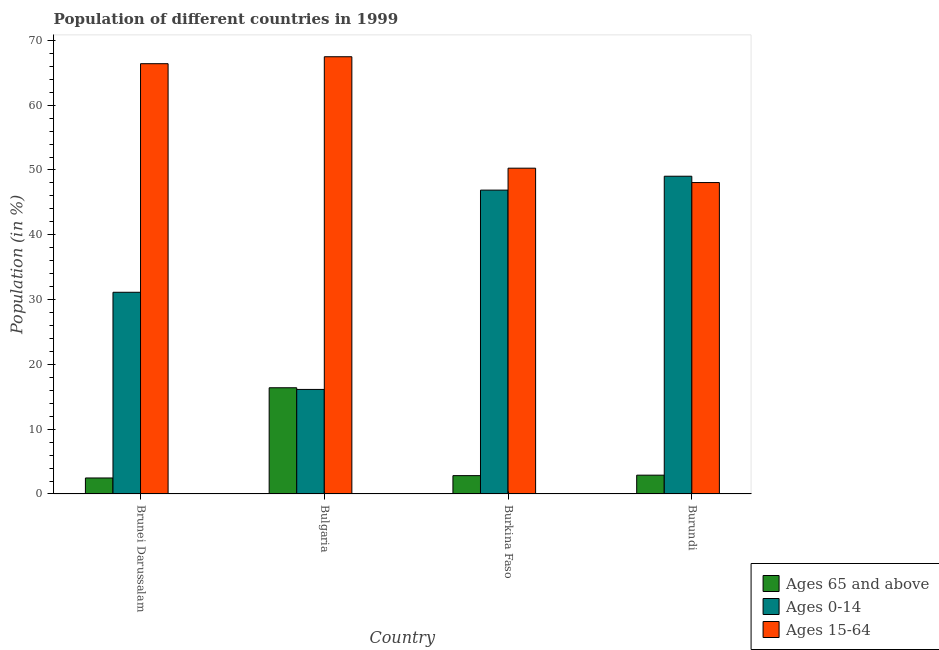How many different coloured bars are there?
Provide a succinct answer. 3. Are the number of bars per tick equal to the number of legend labels?
Your answer should be very brief. Yes. Are the number of bars on each tick of the X-axis equal?
Your response must be concise. Yes. How many bars are there on the 2nd tick from the right?
Give a very brief answer. 3. What is the label of the 1st group of bars from the left?
Your response must be concise. Brunei Darussalam. In how many cases, is the number of bars for a given country not equal to the number of legend labels?
Offer a terse response. 0. What is the percentage of population within the age-group 0-14 in Bulgaria?
Provide a succinct answer. 16.13. Across all countries, what is the maximum percentage of population within the age-group 15-64?
Provide a short and direct response. 67.48. Across all countries, what is the minimum percentage of population within the age-group 0-14?
Offer a very short reply. 16.13. In which country was the percentage of population within the age-group 0-14 maximum?
Make the answer very short. Burundi. In which country was the percentage of population within the age-group 0-14 minimum?
Provide a short and direct response. Bulgaria. What is the total percentage of population within the age-group of 65 and above in the graph?
Your response must be concise. 24.59. What is the difference between the percentage of population within the age-group of 65 and above in Burkina Faso and that in Burundi?
Offer a terse response. -0.07. What is the difference between the percentage of population within the age-group 0-14 in Brunei Darussalam and the percentage of population within the age-group 15-64 in Burundi?
Ensure brevity in your answer.  -16.93. What is the average percentage of population within the age-group 0-14 per country?
Give a very brief answer. 35.8. What is the difference between the percentage of population within the age-group 0-14 and percentage of population within the age-group of 65 and above in Brunei Darussalam?
Ensure brevity in your answer.  28.66. What is the ratio of the percentage of population within the age-group 15-64 in Brunei Darussalam to that in Burkina Faso?
Your answer should be compact. 1.32. Is the difference between the percentage of population within the age-group of 65 and above in Brunei Darussalam and Bulgaria greater than the difference between the percentage of population within the age-group 0-14 in Brunei Darussalam and Bulgaria?
Ensure brevity in your answer.  No. What is the difference between the highest and the second highest percentage of population within the age-group 0-14?
Offer a terse response. 2.14. What is the difference between the highest and the lowest percentage of population within the age-group 15-64?
Your response must be concise. 19.42. In how many countries, is the percentage of population within the age-group of 65 and above greater than the average percentage of population within the age-group of 65 and above taken over all countries?
Ensure brevity in your answer.  1. Is the sum of the percentage of population within the age-group of 65 and above in Brunei Darussalam and Bulgaria greater than the maximum percentage of population within the age-group 0-14 across all countries?
Offer a terse response. No. What does the 2nd bar from the left in Burkina Faso represents?
Your response must be concise. Ages 0-14. What does the 2nd bar from the right in Bulgaria represents?
Keep it short and to the point. Ages 0-14. Is it the case that in every country, the sum of the percentage of population within the age-group of 65 and above and percentage of population within the age-group 0-14 is greater than the percentage of population within the age-group 15-64?
Keep it short and to the point. No. How many bars are there?
Ensure brevity in your answer.  12. How many countries are there in the graph?
Offer a very short reply. 4. What is the difference between two consecutive major ticks on the Y-axis?
Your response must be concise. 10. Does the graph contain grids?
Make the answer very short. No. How many legend labels are there?
Your answer should be very brief. 3. What is the title of the graph?
Provide a succinct answer. Population of different countries in 1999. Does "Gaseous fuel" appear as one of the legend labels in the graph?
Your answer should be very brief. No. What is the label or title of the X-axis?
Offer a terse response. Country. What is the Population (in %) of Ages 65 and above in Brunei Darussalam?
Offer a terse response. 2.47. What is the Population (in %) of Ages 0-14 in Brunei Darussalam?
Keep it short and to the point. 31.13. What is the Population (in %) in Ages 15-64 in Brunei Darussalam?
Make the answer very short. 66.4. What is the Population (in %) of Ages 65 and above in Bulgaria?
Your answer should be very brief. 16.39. What is the Population (in %) in Ages 0-14 in Bulgaria?
Ensure brevity in your answer.  16.13. What is the Population (in %) of Ages 15-64 in Bulgaria?
Give a very brief answer. 67.48. What is the Population (in %) of Ages 65 and above in Burkina Faso?
Your answer should be very brief. 2.83. What is the Population (in %) in Ages 0-14 in Burkina Faso?
Your answer should be compact. 46.89. What is the Population (in %) of Ages 15-64 in Burkina Faso?
Your answer should be compact. 50.28. What is the Population (in %) of Ages 65 and above in Burundi?
Provide a succinct answer. 2.9. What is the Population (in %) in Ages 0-14 in Burundi?
Offer a very short reply. 49.04. What is the Population (in %) in Ages 15-64 in Burundi?
Ensure brevity in your answer.  48.06. Across all countries, what is the maximum Population (in %) of Ages 65 and above?
Make the answer very short. 16.39. Across all countries, what is the maximum Population (in %) of Ages 0-14?
Keep it short and to the point. 49.04. Across all countries, what is the maximum Population (in %) in Ages 15-64?
Ensure brevity in your answer.  67.48. Across all countries, what is the minimum Population (in %) of Ages 65 and above?
Offer a very short reply. 2.47. Across all countries, what is the minimum Population (in %) in Ages 0-14?
Your answer should be very brief. 16.13. Across all countries, what is the minimum Population (in %) of Ages 15-64?
Your answer should be compact. 48.06. What is the total Population (in %) in Ages 65 and above in the graph?
Provide a short and direct response. 24.59. What is the total Population (in %) in Ages 0-14 in the graph?
Give a very brief answer. 143.19. What is the total Population (in %) in Ages 15-64 in the graph?
Ensure brevity in your answer.  232.22. What is the difference between the Population (in %) in Ages 65 and above in Brunei Darussalam and that in Bulgaria?
Provide a succinct answer. -13.92. What is the difference between the Population (in %) of Ages 0-14 in Brunei Darussalam and that in Bulgaria?
Your answer should be compact. 15. What is the difference between the Population (in %) in Ages 15-64 in Brunei Darussalam and that in Bulgaria?
Make the answer very short. -1.07. What is the difference between the Population (in %) in Ages 65 and above in Brunei Darussalam and that in Burkina Faso?
Your answer should be compact. -0.36. What is the difference between the Population (in %) in Ages 0-14 in Brunei Darussalam and that in Burkina Faso?
Ensure brevity in your answer.  -15.76. What is the difference between the Population (in %) in Ages 15-64 in Brunei Darussalam and that in Burkina Faso?
Make the answer very short. 16.12. What is the difference between the Population (in %) in Ages 65 and above in Brunei Darussalam and that in Burundi?
Provide a succinct answer. -0.43. What is the difference between the Population (in %) in Ages 0-14 in Brunei Darussalam and that in Burundi?
Ensure brevity in your answer.  -17.91. What is the difference between the Population (in %) in Ages 15-64 in Brunei Darussalam and that in Burundi?
Make the answer very short. 18.34. What is the difference between the Population (in %) of Ages 65 and above in Bulgaria and that in Burkina Faso?
Your answer should be very brief. 13.56. What is the difference between the Population (in %) of Ages 0-14 in Bulgaria and that in Burkina Faso?
Your response must be concise. -30.76. What is the difference between the Population (in %) in Ages 15-64 in Bulgaria and that in Burkina Faso?
Keep it short and to the point. 17.2. What is the difference between the Population (in %) in Ages 65 and above in Bulgaria and that in Burundi?
Your answer should be very brief. 13.49. What is the difference between the Population (in %) in Ages 0-14 in Bulgaria and that in Burundi?
Provide a short and direct response. -32.9. What is the difference between the Population (in %) in Ages 15-64 in Bulgaria and that in Burundi?
Your answer should be very brief. 19.42. What is the difference between the Population (in %) of Ages 65 and above in Burkina Faso and that in Burundi?
Make the answer very short. -0.07. What is the difference between the Population (in %) of Ages 0-14 in Burkina Faso and that in Burundi?
Your answer should be very brief. -2.14. What is the difference between the Population (in %) of Ages 15-64 in Burkina Faso and that in Burundi?
Make the answer very short. 2.22. What is the difference between the Population (in %) of Ages 65 and above in Brunei Darussalam and the Population (in %) of Ages 0-14 in Bulgaria?
Keep it short and to the point. -13.66. What is the difference between the Population (in %) in Ages 65 and above in Brunei Darussalam and the Population (in %) in Ages 15-64 in Bulgaria?
Offer a terse response. -65.01. What is the difference between the Population (in %) in Ages 0-14 in Brunei Darussalam and the Population (in %) in Ages 15-64 in Bulgaria?
Your answer should be very brief. -36.35. What is the difference between the Population (in %) in Ages 65 and above in Brunei Darussalam and the Population (in %) in Ages 0-14 in Burkina Faso?
Provide a succinct answer. -44.42. What is the difference between the Population (in %) in Ages 65 and above in Brunei Darussalam and the Population (in %) in Ages 15-64 in Burkina Faso?
Offer a very short reply. -47.81. What is the difference between the Population (in %) of Ages 0-14 in Brunei Darussalam and the Population (in %) of Ages 15-64 in Burkina Faso?
Offer a terse response. -19.15. What is the difference between the Population (in %) in Ages 65 and above in Brunei Darussalam and the Population (in %) in Ages 0-14 in Burundi?
Your response must be concise. -46.57. What is the difference between the Population (in %) of Ages 65 and above in Brunei Darussalam and the Population (in %) of Ages 15-64 in Burundi?
Your answer should be very brief. -45.59. What is the difference between the Population (in %) of Ages 0-14 in Brunei Darussalam and the Population (in %) of Ages 15-64 in Burundi?
Make the answer very short. -16.93. What is the difference between the Population (in %) of Ages 65 and above in Bulgaria and the Population (in %) of Ages 0-14 in Burkina Faso?
Your answer should be very brief. -30.5. What is the difference between the Population (in %) in Ages 65 and above in Bulgaria and the Population (in %) in Ages 15-64 in Burkina Faso?
Make the answer very short. -33.89. What is the difference between the Population (in %) in Ages 0-14 in Bulgaria and the Population (in %) in Ages 15-64 in Burkina Faso?
Offer a terse response. -34.15. What is the difference between the Population (in %) in Ages 65 and above in Bulgaria and the Population (in %) in Ages 0-14 in Burundi?
Provide a short and direct response. -32.65. What is the difference between the Population (in %) of Ages 65 and above in Bulgaria and the Population (in %) of Ages 15-64 in Burundi?
Your answer should be compact. -31.67. What is the difference between the Population (in %) in Ages 0-14 in Bulgaria and the Population (in %) in Ages 15-64 in Burundi?
Give a very brief answer. -31.93. What is the difference between the Population (in %) in Ages 65 and above in Burkina Faso and the Population (in %) in Ages 0-14 in Burundi?
Your response must be concise. -46.21. What is the difference between the Population (in %) of Ages 65 and above in Burkina Faso and the Population (in %) of Ages 15-64 in Burundi?
Provide a short and direct response. -45.23. What is the difference between the Population (in %) of Ages 0-14 in Burkina Faso and the Population (in %) of Ages 15-64 in Burundi?
Provide a short and direct response. -1.17. What is the average Population (in %) of Ages 65 and above per country?
Provide a succinct answer. 6.15. What is the average Population (in %) of Ages 0-14 per country?
Keep it short and to the point. 35.8. What is the average Population (in %) of Ages 15-64 per country?
Give a very brief answer. 58.05. What is the difference between the Population (in %) in Ages 65 and above and Population (in %) in Ages 0-14 in Brunei Darussalam?
Give a very brief answer. -28.66. What is the difference between the Population (in %) in Ages 65 and above and Population (in %) in Ages 15-64 in Brunei Darussalam?
Ensure brevity in your answer.  -63.93. What is the difference between the Population (in %) of Ages 0-14 and Population (in %) of Ages 15-64 in Brunei Darussalam?
Provide a succinct answer. -35.27. What is the difference between the Population (in %) of Ages 65 and above and Population (in %) of Ages 0-14 in Bulgaria?
Make the answer very short. 0.26. What is the difference between the Population (in %) in Ages 65 and above and Population (in %) in Ages 15-64 in Bulgaria?
Your response must be concise. -51.09. What is the difference between the Population (in %) of Ages 0-14 and Population (in %) of Ages 15-64 in Bulgaria?
Keep it short and to the point. -51.34. What is the difference between the Population (in %) in Ages 65 and above and Population (in %) in Ages 0-14 in Burkina Faso?
Keep it short and to the point. -44.06. What is the difference between the Population (in %) in Ages 65 and above and Population (in %) in Ages 15-64 in Burkina Faso?
Offer a terse response. -47.45. What is the difference between the Population (in %) of Ages 0-14 and Population (in %) of Ages 15-64 in Burkina Faso?
Your answer should be very brief. -3.39. What is the difference between the Population (in %) of Ages 65 and above and Population (in %) of Ages 0-14 in Burundi?
Your response must be concise. -46.13. What is the difference between the Population (in %) of Ages 65 and above and Population (in %) of Ages 15-64 in Burundi?
Make the answer very short. -45.16. What is the difference between the Population (in %) in Ages 0-14 and Population (in %) in Ages 15-64 in Burundi?
Give a very brief answer. 0.98. What is the ratio of the Population (in %) in Ages 65 and above in Brunei Darussalam to that in Bulgaria?
Keep it short and to the point. 0.15. What is the ratio of the Population (in %) of Ages 0-14 in Brunei Darussalam to that in Bulgaria?
Offer a terse response. 1.93. What is the ratio of the Population (in %) of Ages 15-64 in Brunei Darussalam to that in Bulgaria?
Your answer should be compact. 0.98. What is the ratio of the Population (in %) in Ages 65 and above in Brunei Darussalam to that in Burkina Faso?
Your answer should be very brief. 0.87. What is the ratio of the Population (in %) in Ages 0-14 in Brunei Darussalam to that in Burkina Faso?
Make the answer very short. 0.66. What is the ratio of the Population (in %) of Ages 15-64 in Brunei Darussalam to that in Burkina Faso?
Keep it short and to the point. 1.32. What is the ratio of the Population (in %) in Ages 65 and above in Brunei Darussalam to that in Burundi?
Provide a short and direct response. 0.85. What is the ratio of the Population (in %) of Ages 0-14 in Brunei Darussalam to that in Burundi?
Your answer should be very brief. 0.63. What is the ratio of the Population (in %) in Ages 15-64 in Brunei Darussalam to that in Burundi?
Provide a succinct answer. 1.38. What is the ratio of the Population (in %) of Ages 65 and above in Bulgaria to that in Burkina Faso?
Make the answer very short. 5.79. What is the ratio of the Population (in %) of Ages 0-14 in Bulgaria to that in Burkina Faso?
Your answer should be very brief. 0.34. What is the ratio of the Population (in %) of Ages 15-64 in Bulgaria to that in Burkina Faso?
Your response must be concise. 1.34. What is the ratio of the Population (in %) of Ages 65 and above in Bulgaria to that in Burundi?
Provide a succinct answer. 5.65. What is the ratio of the Population (in %) of Ages 0-14 in Bulgaria to that in Burundi?
Keep it short and to the point. 0.33. What is the ratio of the Population (in %) of Ages 15-64 in Bulgaria to that in Burundi?
Keep it short and to the point. 1.4. What is the ratio of the Population (in %) in Ages 65 and above in Burkina Faso to that in Burundi?
Give a very brief answer. 0.97. What is the ratio of the Population (in %) in Ages 0-14 in Burkina Faso to that in Burundi?
Make the answer very short. 0.96. What is the ratio of the Population (in %) of Ages 15-64 in Burkina Faso to that in Burundi?
Provide a succinct answer. 1.05. What is the difference between the highest and the second highest Population (in %) of Ages 65 and above?
Your answer should be very brief. 13.49. What is the difference between the highest and the second highest Population (in %) in Ages 0-14?
Keep it short and to the point. 2.14. What is the difference between the highest and the second highest Population (in %) of Ages 15-64?
Your response must be concise. 1.07. What is the difference between the highest and the lowest Population (in %) of Ages 65 and above?
Your response must be concise. 13.92. What is the difference between the highest and the lowest Population (in %) in Ages 0-14?
Provide a short and direct response. 32.9. What is the difference between the highest and the lowest Population (in %) of Ages 15-64?
Make the answer very short. 19.42. 